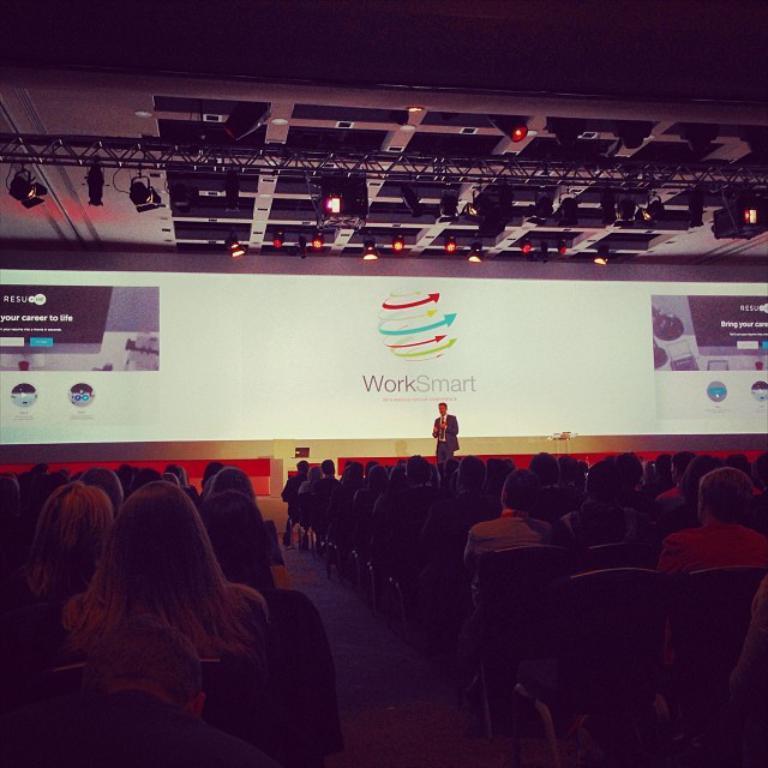Can you describe this image briefly? In this image we can see a person standing on the stage. We can also see a group of people sitting in front of him on the chairs. On the backside we can see a projector and a roof. 